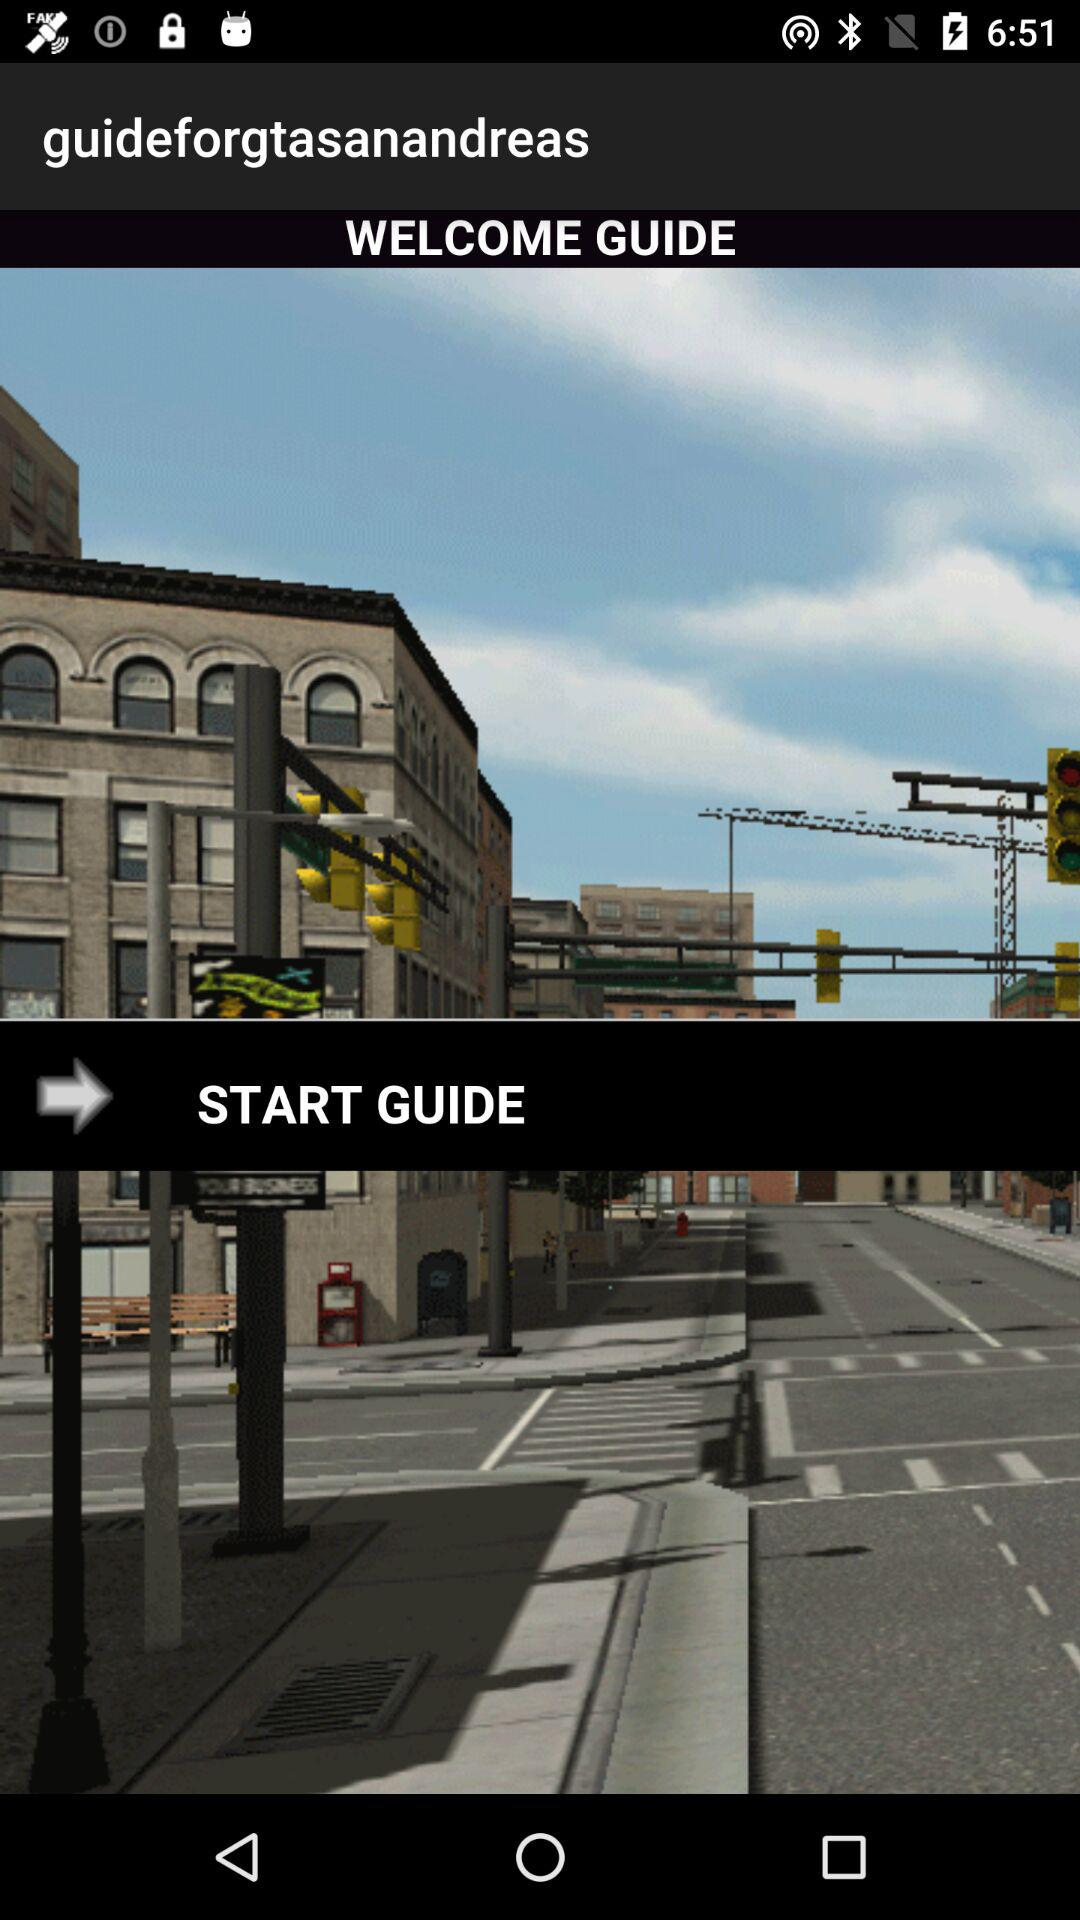What is the application name? The application name is "guideforgtasanandreas". 